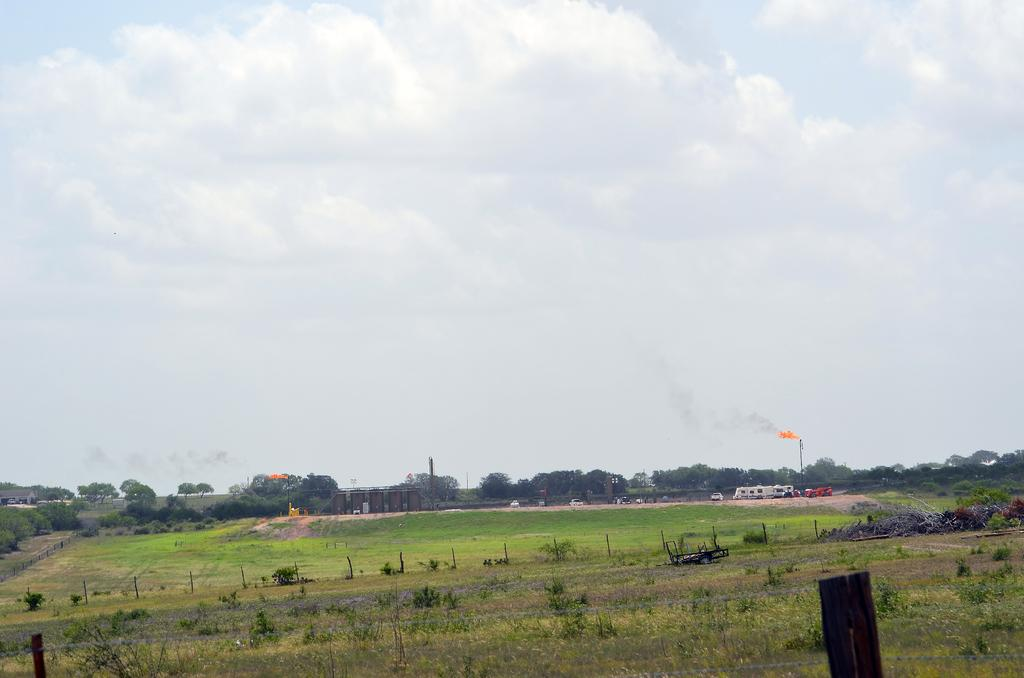What type of vegetation is at the bottom of the image? There are plants at the bottom of the image. What is happening on the right side of the image? There appears to be fire on the right side of the image. What can be seen in the background of the image? There are trees in the background of the image. What is visible at the top of the image? The sky is visible at the top of the image. Where is the zipper located in the image? There is no zipper present in the image. What type of credit can be seen being used in the image? There is no credit or financial transaction depicted in the image. 